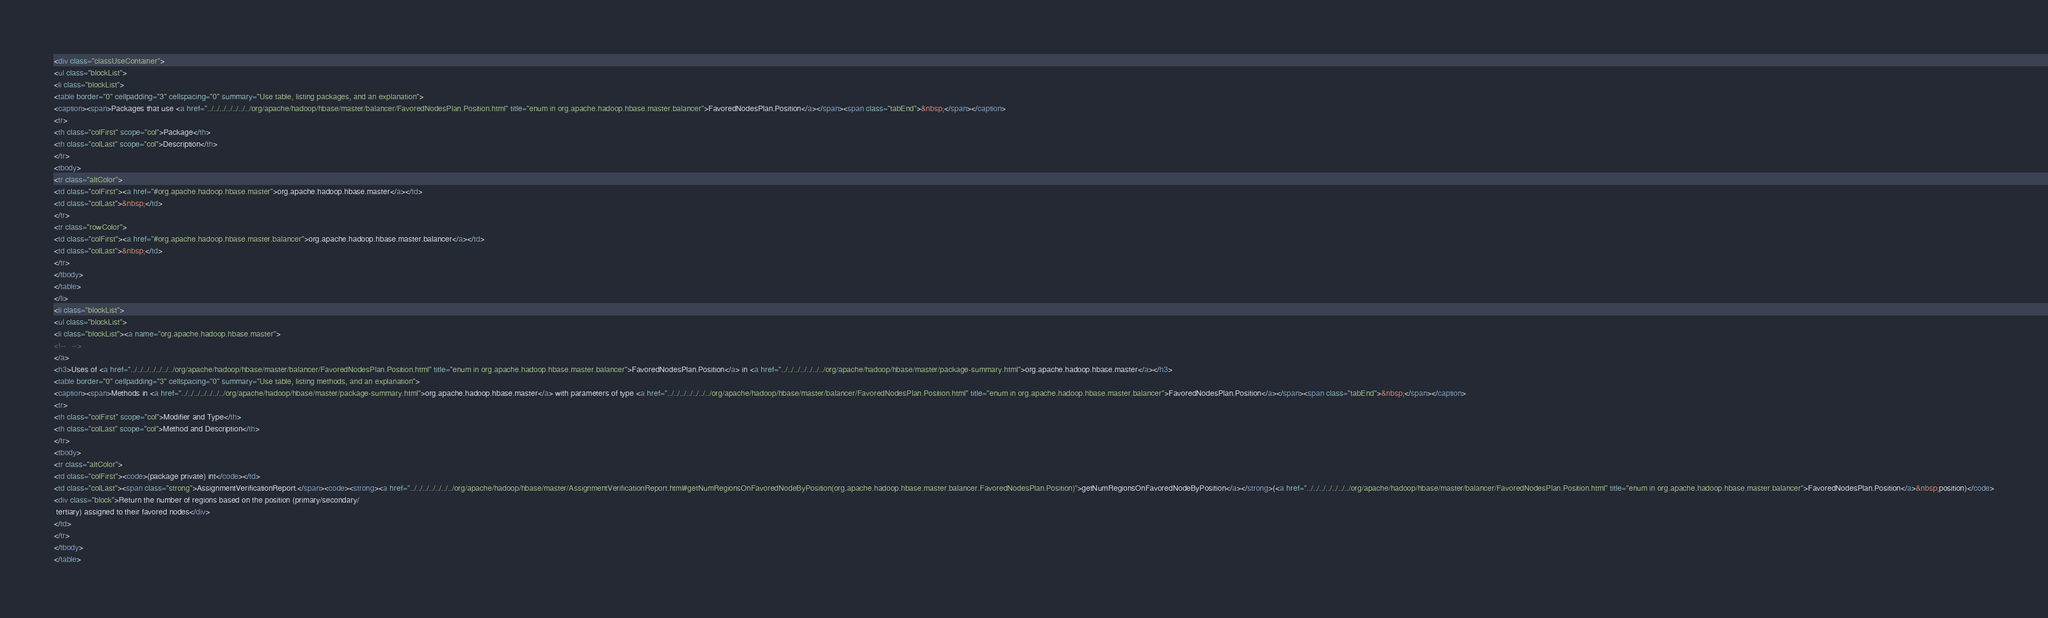<code> <loc_0><loc_0><loc_500><loc_500><_HTML_><div class="classUseContainer">
<ul class="blockList">
<li class="blockList">
<table border="0" cellpadding="3" cellspacing="0" summary="Use table, listing packages, and an explanation">
<caption><span>Packages that use <a href="../../../../../../../org/apache/hadoop/hbase/master/balancer/FavoredNodesPlan.Position.html" title="enum in org.apache.hadoop.hbase.master.balancer">FavoredNodesPlan.Position</a></span><span class="tabEnd">&nbsp;</span></caption>
<tr>
<th class="colFirst" scope="col">Package</th>
<th class="colLast" scope="col">Description</th>
</tr>
<tbody>
<tr class="altColor">
<td class="colFirst"><a href="#org.apache.hadoop.hbase.master">org.apache.hadoop.hbase.master</a></td>
<td class="colLast">&nbsp;</td>
</tr>
<tr class="rowColor">
<td class="colFirst"><a href="#org.apache.hadoop.hbase.master.balancer">org.apache.hadoop.hbase.master.balancer</a></td>
<td class="colLast">&nbsp;</td>
</tr>
</tbody>
</table>
</li>
<li class="blockList">
<ul class="blockList">
<li class="blockList"><a name="org.apache.hadoop.hbase.master">
<!--   -->
</a>
<h3>Uses of <a href="../../../../../../../org/apache/hadoop/hbase/master/balancer/FavoredNodesPlan.Position.html" title="enum in org.apache.hadoop.hbase.master.balancer">FavoredNodesPlan.Position</a> in <a href="../../../../../../../org/apache/hadoop/hbase/master/package-summary.html">org.apache.hadoop.hbase.master</a></h3>
<table border="0" cellpadding="3" cellspacing="0" summary="Use table, listing methods, and an explanation">
<caption><span>Methods in <a href="../../../../../../../org/apache/hadoop/hbase/master/package-summary.html">org.apache.hadoop.hbase.master</a> with parameters of type <a href="../../../../../../../org/apache/hadoop/hbase/master/balancer/FavoredNodesPlan.Position.html" title="enum in org.apache.hadoop.hbase.master.balancer">FavoredNodesPlan.Position</a></span><span class="tabEnd">&nbsp;</span></caption>
<tr>
<th class="colFirst" scope="col">Modifier and Type</th>
<th class="colLast" scope="col">Method and Description</th>
</tr>
<tbody>
<tr class="altColor">
<td class="colFirst"><code>(package private) int</code></td>
<td class="colLast"><span class="strong">AssignmentVerificationReport.</span><code><strong><a href="../../../../../../../org/apache/hadoop/hbase/master/AssignmentVerificationReport.html#getNumRegionsOnFavoredNodeByPosition(org.apache.hadoop.hbase.master.balancer.FavoredNodesPlan.Position)">getNumRegionsOnFavoredNodeByPosition</a></strong>(<a href="../../../../../../../org/apache/hadoop/hbase/master/balancer/FavoredNodesPlan.Position.html" title="enum in org.apache.hadoop.hbase.master.balancer">FavoredNodesPlan.Position</a>&nbsp;position)</code>
<div class="block">Return the number of regions based on the position (primary/secondary/
 tertiary) assigned to their favored nodes</div>
</td>
</tr>
</tbody>
</table></code> 